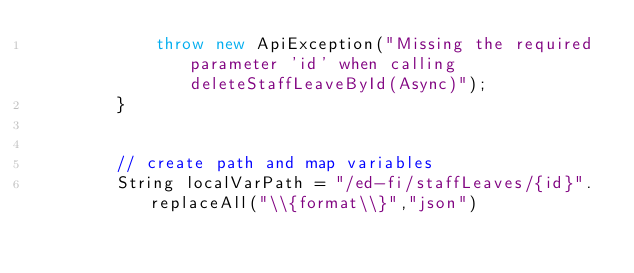<code> <loc_0><loc_0><loc_500><loc_500><_Java_>            throw new ApiException("Missing the required parameter 'id' when calling deleteStaffLeaveById(Async)");
        }
        

        // create path and map variables
        String localVarPath = "/ed-fi/staffLeaves/{id}".replaceAll("\\{format\\}","json")</code> 